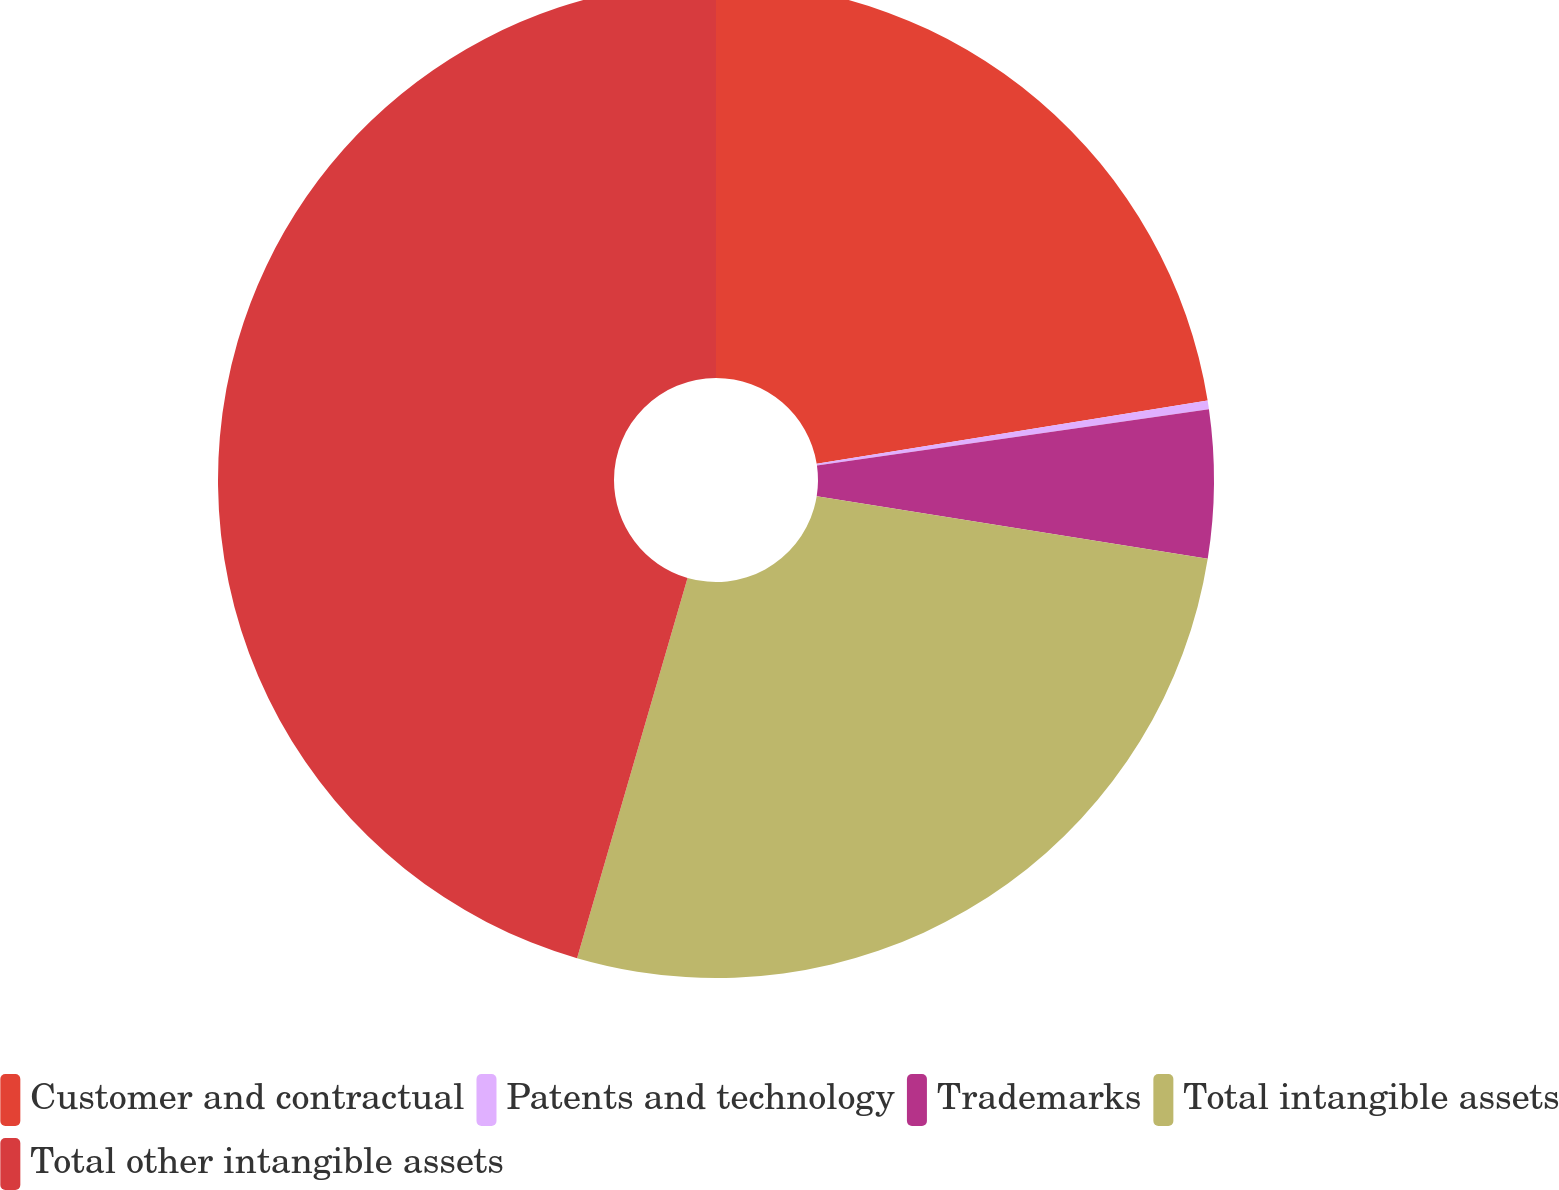Convert chart to OTSL. <chart><loc_0><loc_0><loc_500><loc_500><pie_chart><fcel>Customer and contractual<fcel>Patents and technology<fcel>Trademarks<fcel>Total intangible assets<fcel>Total other intangible assets<nl><fcel>22.45%<fcel>0.28%<fcel>4.8%<fcel>26.97%<fcel>45.5%<nl></chart> 